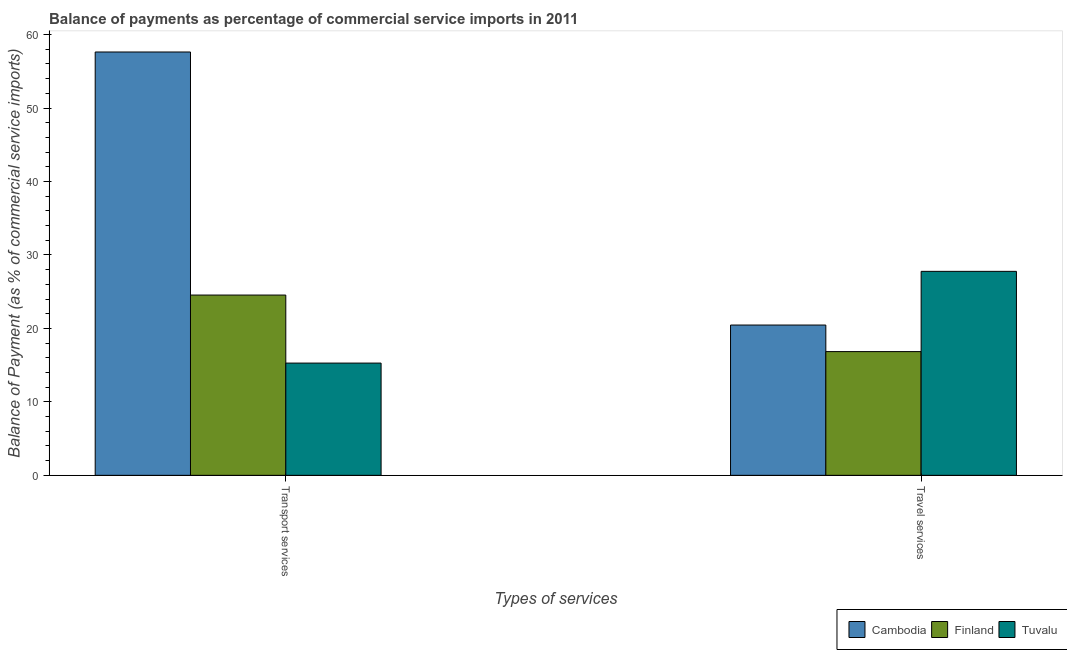How many groups of bars are there?
Your answer should be very brief. 2. How many bars are there on the 1st tick from the left?
Provide a succinct answer. 3. How many bars are there on the 2nd tick from the right?
Your response must be concise. 3. What is the label of the 1st group of bars from the left?
Ensure brevity in your answer.  Transport services. What is the balance of payments of travel services in Finland?
Offer a terse response. 16.85. Across all countries, what is the maximum balance of payments of transport services?
Offer a terse response. 57.63. Across all countries, what is the minimum balance of payments of travel services?
Ensure brevity in your answer.  16.85. In which country was the balance of payments of travel services maximum?
Your answer should be compact. Tuvalu. In which country was the balance of payments of travel services minimum?
Make the answer very short. Finland. What is the total balance of payments of transport services in the graph?
Offer a very short reply. 97.46. What is the difference between the balance of payments of travel services in Finland and that in Tuvalu?
Provide a short and direct response. -10.93. What is the difference between the balance of payments of travel services in Finland and the balance of payments of transport services in Cambodia?
Provide a succinct answer. -40.79. What is the average balance of payments of transport services per country?
Ensure brevity in your answer.  32.49. What is the difference between the balance of payments of transport services and balance of payments of travel services in Finland?
Your response must be concise. 7.7. What is the ratio of the balance of payments of transport services in Cambodia to that in Tuvalu?
Give a very brief answer. 3.77. In how many countries, is the balance of payments of travel services greater than the average balance of payments of travel services taken over all countries?
Keep it short and to the point. 1. What does the 3rd bar from the left in Travel services represents?
Provide a short and direct response. Tuvalu. What does the 1st bar from the right in Transport services represents?
Offer a very short reply. Tuvalu. How many countries are there in the graph?
Make the answer very short. 3. Are the values on the major ticks of Y-axis written in scientific E-notation?
Your answer should be compact. No. Does the graph contain any zero values?
Offer a terse response. No. Does the graph contain grids?
Give a very brief answer. No. Where does the legend appear in the graph?
Offer a very short reply. Bottom right. What is the title of the graph?
Ensure brevity in your answer.  Balance of payments as percentage of commercial service imports in 2011. What is the label or title of the X-axis?
Your answer should be compact. Types of services. What is the label or title of the Y-axis?
Keep it short and to the point. Balance of Payment (as % of commercial service imports). What is the Balance of Payment (as % of commercial service imports) of Cambodia in Transport services?
Make the answer very short. 57.63. What is the Balance of Payment (as % of commercial service imports) in Finland in Transport services?
Give a very brief answer. 24.54. What is the Balance of Payment (as % of commercial service imports) in Tuvalu in Transport services?
Ensure brevity in your answer.  15.28. What is the Balance of Payment (as % of commercial service imports) in Cambodia in Travel services?
Give a very brief answer. 20.46. What is the Balance of Payment (as % of commercial service imports) in Finland in Travel services?
Your answer should be compact. 16.85. What is the Balance of Payment (as % of commercial service imports) of Tuvalu in Travel services?
Keep it short and to the point. 27.77. Across all Types of services, what is the maximum Balance of Payment (as % of commercial service imports) in Cambodia?
Provide a succinct answer. 57.63. Across all Types of services, what is the maximum Balance of Payment (as % of commercial service imports) of Finland?
Provide a succinct answer. 24.54. Across all Types of services, what is the maximum Balance of Payment (as % of commercial service imports) in Tuvalu?
Your response must be concise. 27.77. Across all Types of services, what is the minimum Balance of Payment (as % of commercial service imports) of Cambodia?
Give a very brief answer. 20.46. Across all Types of services, what is the minimum Balance of Payment (as % of commercial service imports) in Finland?
Your answer should be compact. 16.85. Across all Types of services, what is the minimum Balance of Payment (as % of commercial service imports) of Tuvalu?
Offer a very short reply. 15.28. What is the total Balance of Payment (as % of commercial service imports) in Cambodia in the graph?
Your response must be concise. 78.1. What is the total Balance of Payment (as % of commercial service imports) in Finland in the graph?
Your response must be concise. 41.39. What is the total Balance of Payment (as % of commercial service imports) of Tuvalu in the graph?
Make the answer very short. 43.05. What is the difference between the Balance of Payment (as % of commercial service imports) of Cambodia in Transport services and that in Travel services?
Offer a terse response. 37.17. What is the difference between the Balance of Payment (as % of commercial service imports) of Finland in Transport services and that in Travel services?
Ensure brevity in your answer.  7.7. What is the difference between the Balance of Payment (as % of commercial service imports) of Tuvalu in Transport services and that in Travel services?
Give a very brief answer. -12.49. What is the difference between the Balance of Payment (as % of commercial service imports) in Cambodia in Transport services and the Balance of Payment (as % of commercial service imports) in Finland in Travel services?
Your answer should be compact. 40.79. What is the difference between the Balance of Payment (as % of commercial service imports) of Cambodia in Transport services and the Balance of Payment (as % of commercial service imports) of Tuvalu in Travel services?
Provide a succinct answer. 29.86. What is the difference between the Balance of Payment (as % of commercial service imports) of Finland in Transport services and the Balance of Payment (as % of commercial service imports) of Tuvalu in Travel services?
Ensure brevity in your answer.  -3.23. What is the average Balance of Payment (as % of commercial service imports) of Cambodia per Types of services?
Your answer should be compact. 39.05. What is the average Balance of Payment (as % of commercial service imports) in Finland per Types of services?
Keep it short and to the point. 20.69. What is the average Balance of Payment (as % of commercial service imports) of Tuvalu per Types of services?
Offer a very short reply. 21.53. What is the difference between the Balance of Payment (as % of commercial service imports) in Cambodia and Balance of Payment (as % of commercial service imports) in Finland in Transport services?
Provide a short and direct response. 33.09. What is the difference between the Balance of Payment (as % of commercial service imports) in Cambodia and Balance of Payment (as % of commercial service imports) in Tuvalu in Transport services?
Make the answer very short. 42.35. What is the difference between the Balance of Payment (as % of commercial service imports) of Finland and Balance of Payment (as % of commercial service imports) of Tuvalu in Transport services?
Your answer should be very brief. 9.26. What is the difference between the Balance of Payment (as % of commercial service imports) in Cambodia and Balance of Payment (as % of commercial service imports) in Finland in Travel services?
Provide a succinct answer. 3.62. What is the difference between the Balance of Payment (as % of commercial service imports) in Cambodia and Balance of Payment (as % of commercial service imports) in Tuvalu in Travel services?
Provide a short and direct response. -7.31. What is the difference between the Balance of Payment (as % of commercial service imports) of Finland and Balance of Payment (as % of commercial service imports) of Tuvalu in Travel services?
Keep it short and to the point. -10.93. What is the ratio of the Balance of Payment (as % of commercial service imports) in Cambodia in Transport services to that in Travel services?
Make the answer very short. 2.82. What is the ratio of the Balance of Payment (as % of commercial service imports) in Finland in Transport services to that in Travel services?
Your answer should be very brief. 1.46. What is the ratio of the Balance of Payment (as % of commercial service imports) of Tuvalu in Transport services to that in Travel services?
Your answer should be very brief. 0.55. What is the difference between the highest and the second highest Balance of Payment (as % of commercial service imports) of Cambodia?
Your response must be concise. 37.17. What is the difference between the highest and the second highest Balance of Payment (as % of commercial service imports) of Finland?
Offer a terse response. 7.7. What is the difference between the highest and the second highest Balance of Payment (as % of commercial service imports) of Tuvalu?
Give a very brief answer. 12.49. What is the difference between the highest and the lowest Balance of Payment (as % of commercial service imports) in Cambodia?
Offer a terse response. 37.17. What is the difference between the highest and the lowest Balance of Payment (as % of commercial service imports) of Finland?
Give a very brief answer. 7.7. What is the difference between the highest and the lowest Balance of Payment (as % of commercial service imports) of Tuvalu?
Provide a succinct answer. 12.49. 